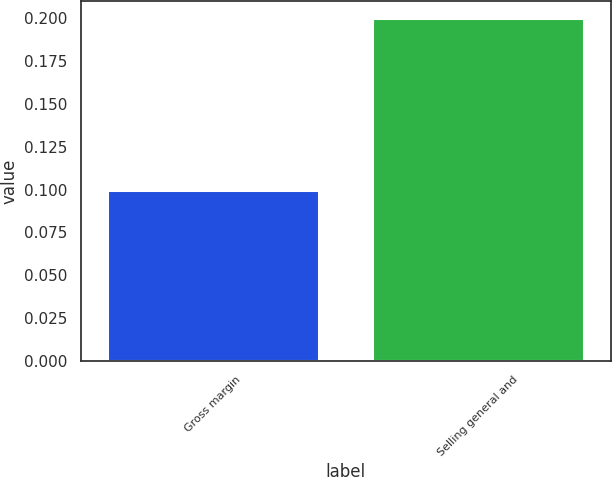Convert chart. <chart><loc_0><loc_0><loc_500><loc_500><bar_chart><fcel>Gross margin<fcel>Selling general and<nl><fcel>0.1<fcel>0.2<nl></chart> 